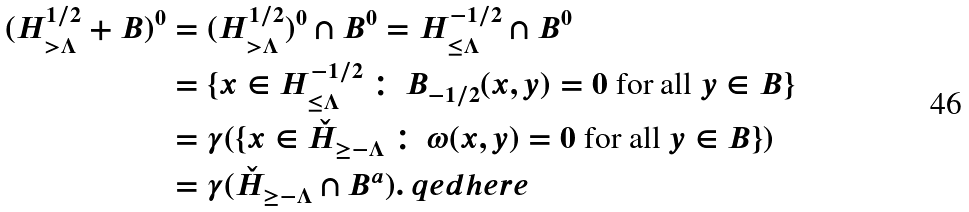<formula> <loc_0><loc_0><loc_500><loc_500>( H _ { > \Lambda } ^ { 1 / 2 } + B ) ^ { 0 } & = ( H _ { > \Lambda } ^ { 1 / 2 } ) ^ { 0 } \cap B ^ { 0 } = H _ { \leq \Lambda } ^ { - 1 / 2 } \cap B ^ { 0 } \\ & = \{ x \in H _ { \leq \Lambda } ^ { - 1 / 2 } \, \colon \, \text {$B_{-1/2}(x,y)=0$ for all $y\in B$} \} \\ & = \gamma ( \{ x \in \check { H } _ { \geq - \Lambda } \, \colon \, \text {$\omega(x,y)=0$ for all $y\in B$} \} ) \\ & = \gamma ( \check { H } _ { \geq - \Lambda } \cap B ^ { a } ) . \ q e d h e r e</formula> 